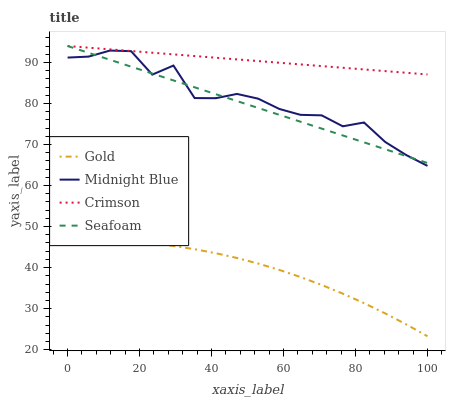Does Midnight Blue have the minimum area under the curve?
Answer yes or no. No. Does Midnight Blue have the maximum area under the curve?
Answer yes or no. No. Is Gold the smoothest?
Answer yes or no. No. Is Gold the roughest?
Answer yes or no. No. Does Midnight Blue have the lowest value?
Answer yes or no. No. Does Midnight Blue have the highest value?
Answer yes or no. No. Is Gold less than Seafoam?
Answer yes or no. Yes. Is Midnight Blue greater than Gold?
Answer yes or no. Yes. Does Gold intersect Seafoam?
Answer yes or no. No. 